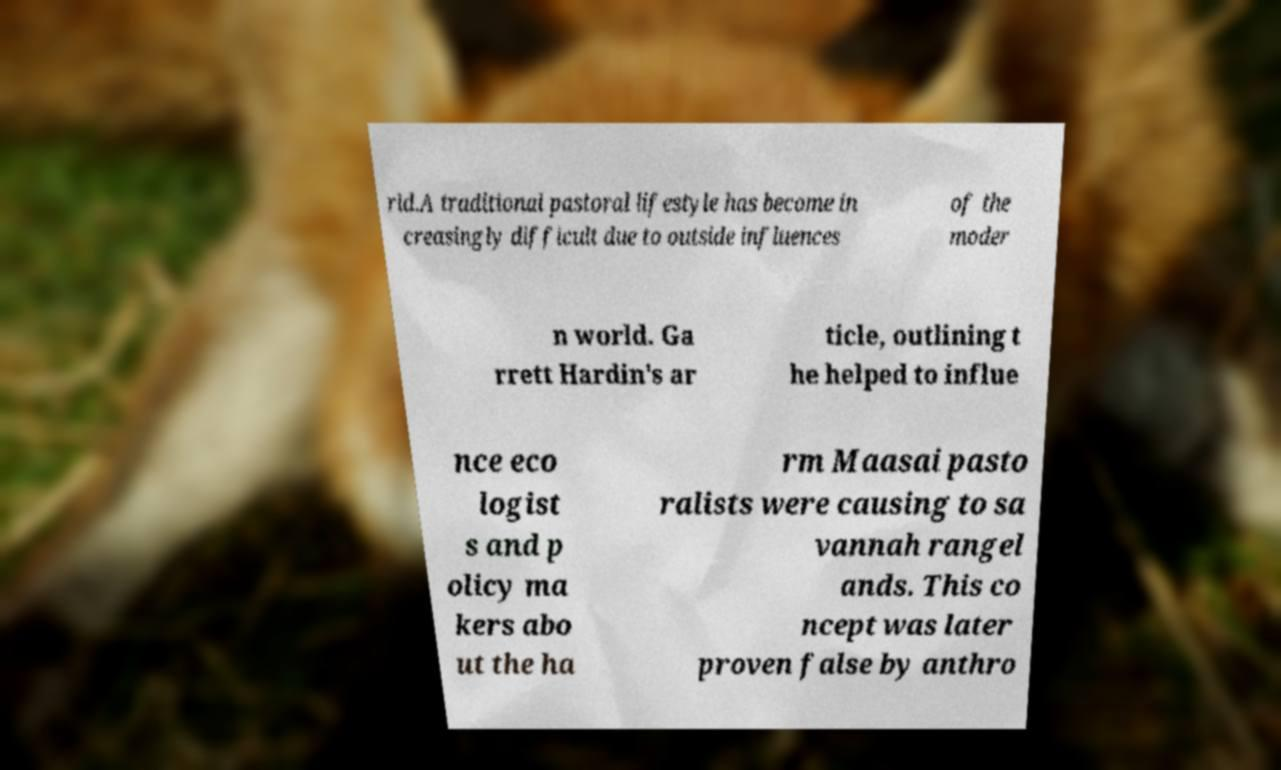Can you accurately transcribe the text from the provided image for me? rld.A traditional pastoral lifestyle has become in creasingly difficult due to outside influences of the moder n world. Ga rrett Hardin's ar ticle, outlining t he helped to influe nce eco logist s and p olicy ma kers abo ut the ha rm Maasai pasto ralists were causing to sa vannah rangel ands. This co ncept was later proven false by anthro 